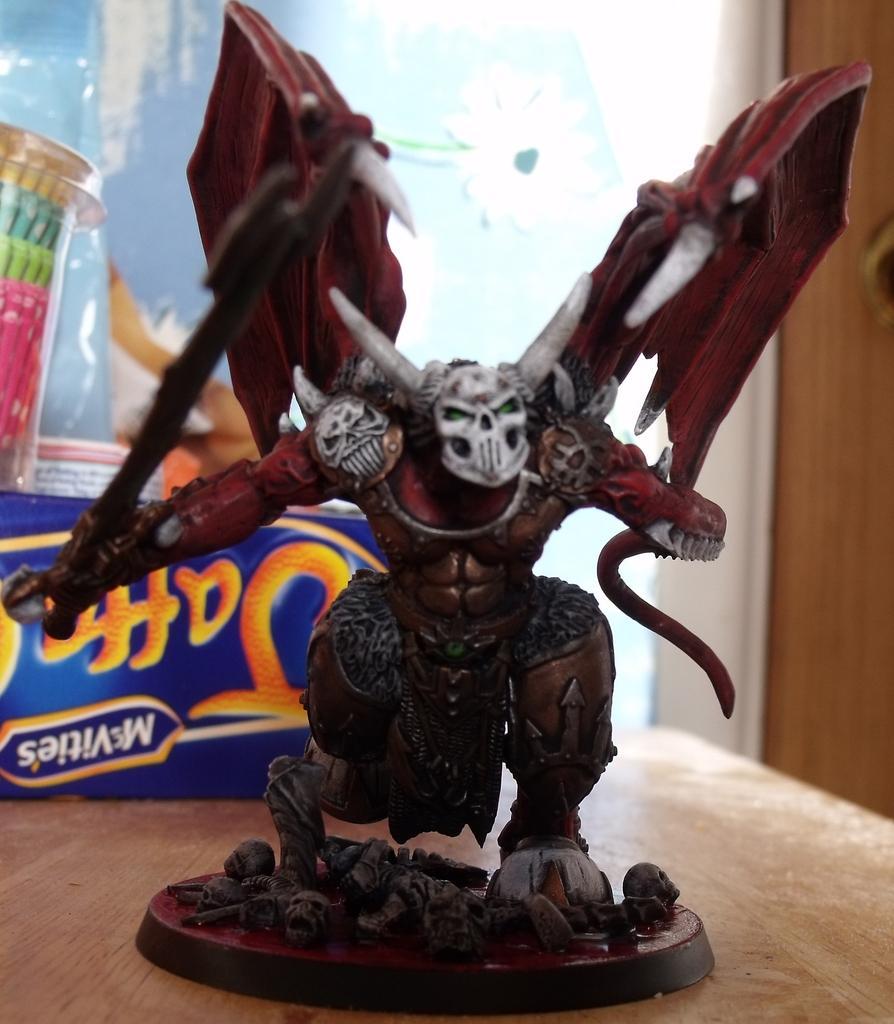In one or two sentences, can you explain what this image depicts? In this picture we can see a statue of a monster on a platform. On this platform, we can see a few skulls. This statue is on a wooden table. There is a box and a colorful object is visible on this box. We can see a wooden object in the background. 